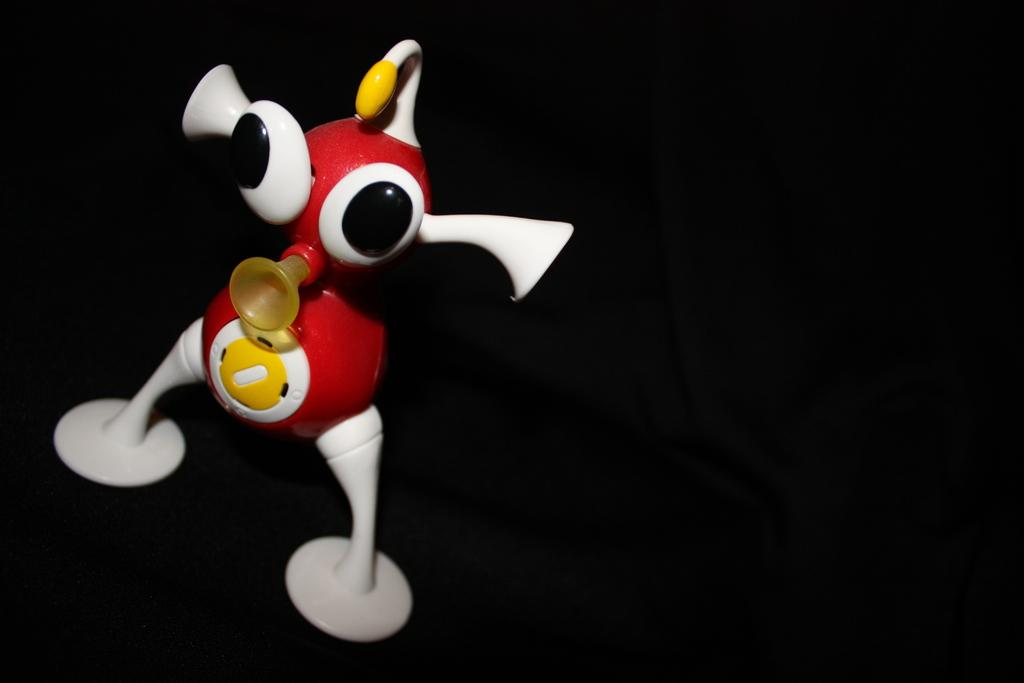What is the main object in the image? There is a toy in the image. What colors can be seen on the toy? The toy has red, white, and yellow colors. What color is the background of the image? The background of the image is black. How many frogs are sitting on the library shelves in the image? There are no frogs or library shelves present in the image. Is there a beggar visible in the image? There is no beggar present in the image. 